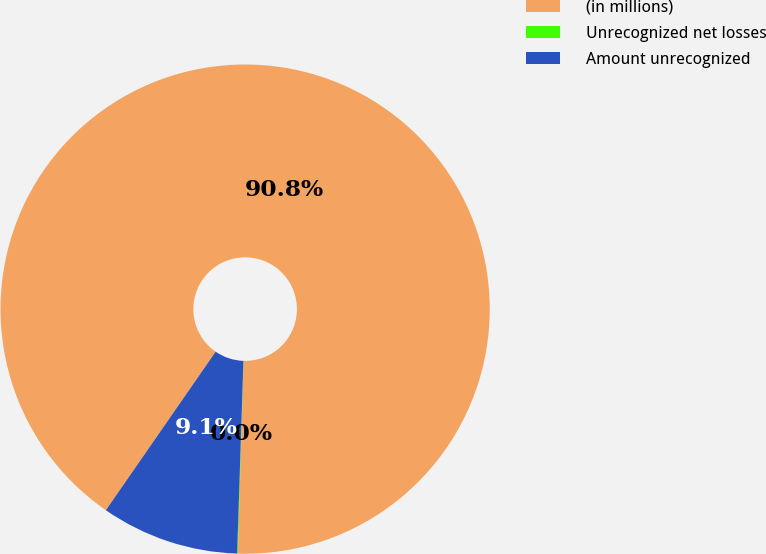<chart> <loc_0><loc_0><loc_500><loc_500><pie_chart><fcel>(in millions)<fcel>Unrecognized net losses<fcel>Amount unrecognized<nl><fcel>90.83%<fcel>0.05%<fcel>9.12%<nl></chart> 